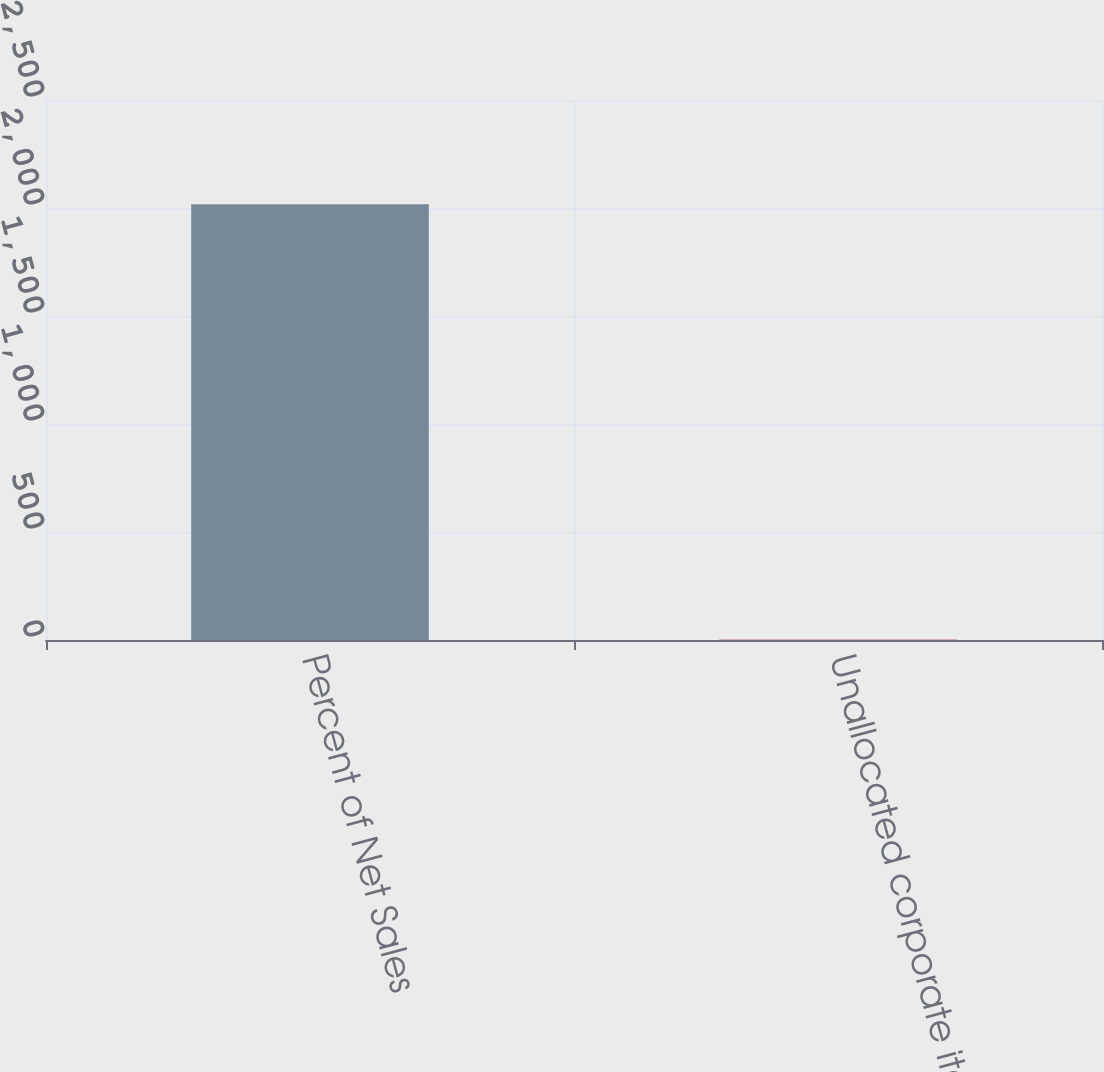Convert chart. <chart><loc_0><loc_0><loc_500><loc_500><bar_chart><fcel>Percent of Net Sales<fcel>Unallocated corporate items<nl><fcel>2017<fcel>1.2<nl></chart> 